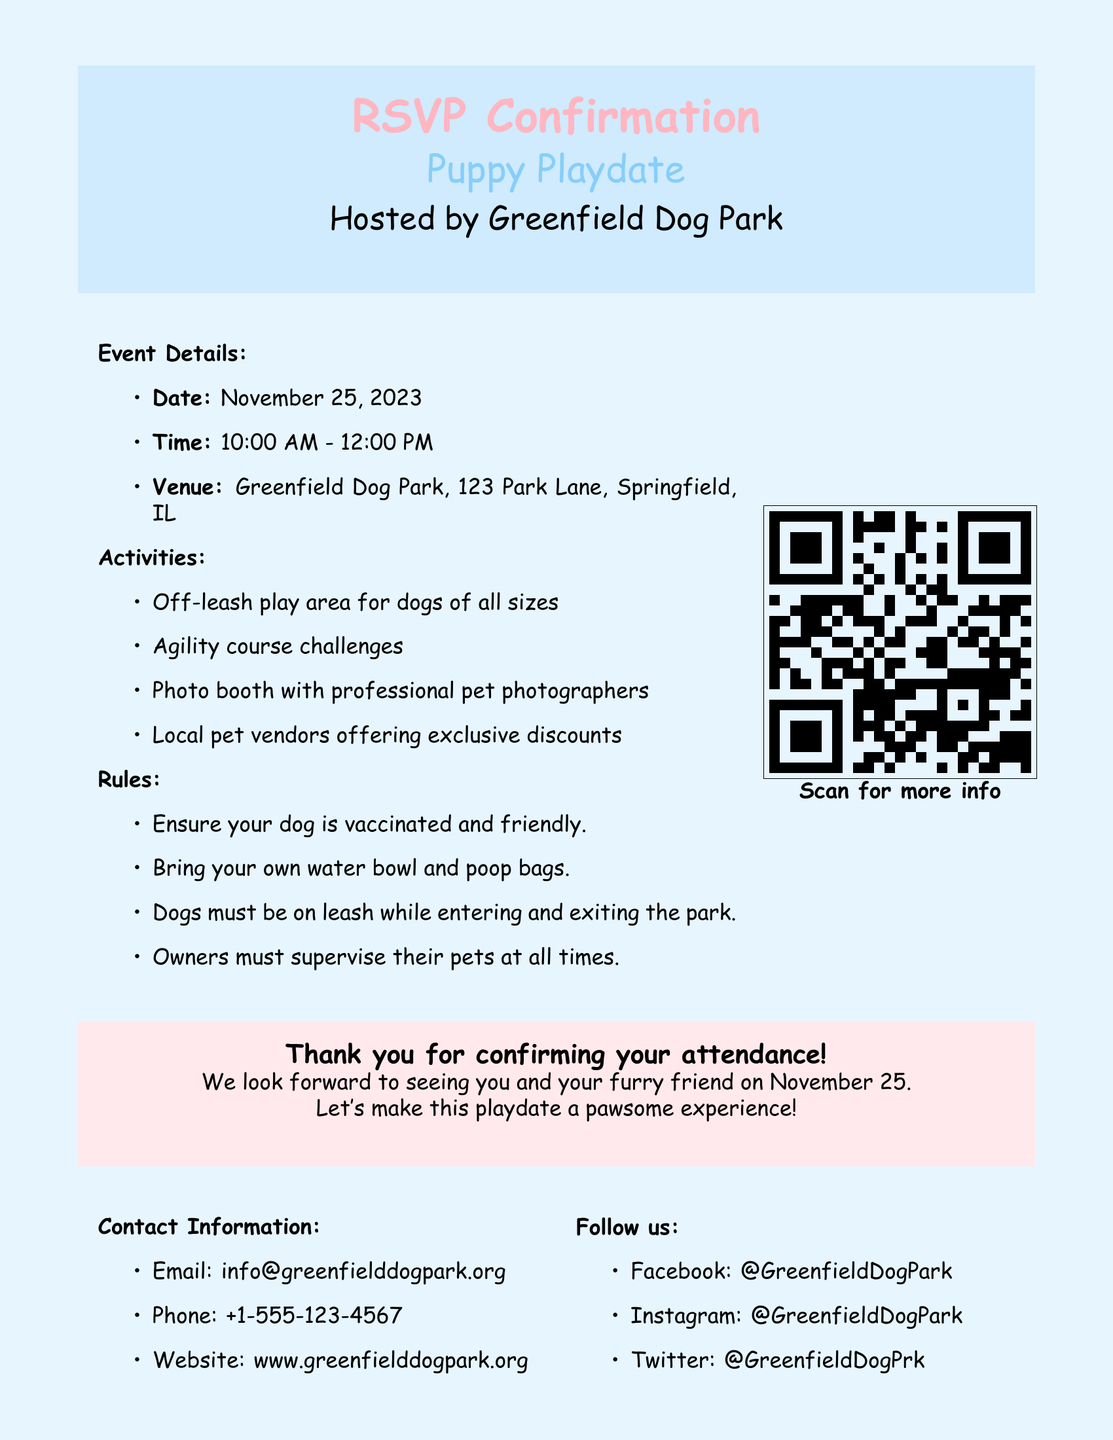What is the date of the event? The date of the event is clearly stated in the document.
Answer: November 25, 2023 What time does the puppy playdate start? The starting time of the event is mentioned in the event details section.
Answer: 10:00 AM Where is the venue located? The venue's location is provided in the event details section of the document.
Answer: Greenfield Dog Park, 123 Park Lane, Springfield, IL What activities are available at the playdate? The activities listed in the document detail what attendees can expect at the event.
Answer: Off-leash play area for dogs of all sizes, agility course challenges, photo booth, local pet vendors What must dogs do while entering and exiting the park? The rules section specifies what dogs must do in this context.
Answer: Be on leash Who can I contact for more information? The document provides contact information in a dedicated section.
Answer: info@greenfielddogpark.org What social media platforms is the dog park on? The follow us section lists the social media platforms where the dog park can be found.
Answer: Facebook, Instagram, Twitter What is required from dog owners during the event? The rules outline responsibilities for dog owners during the playdate.
Answer: Supervise their pets at all times 